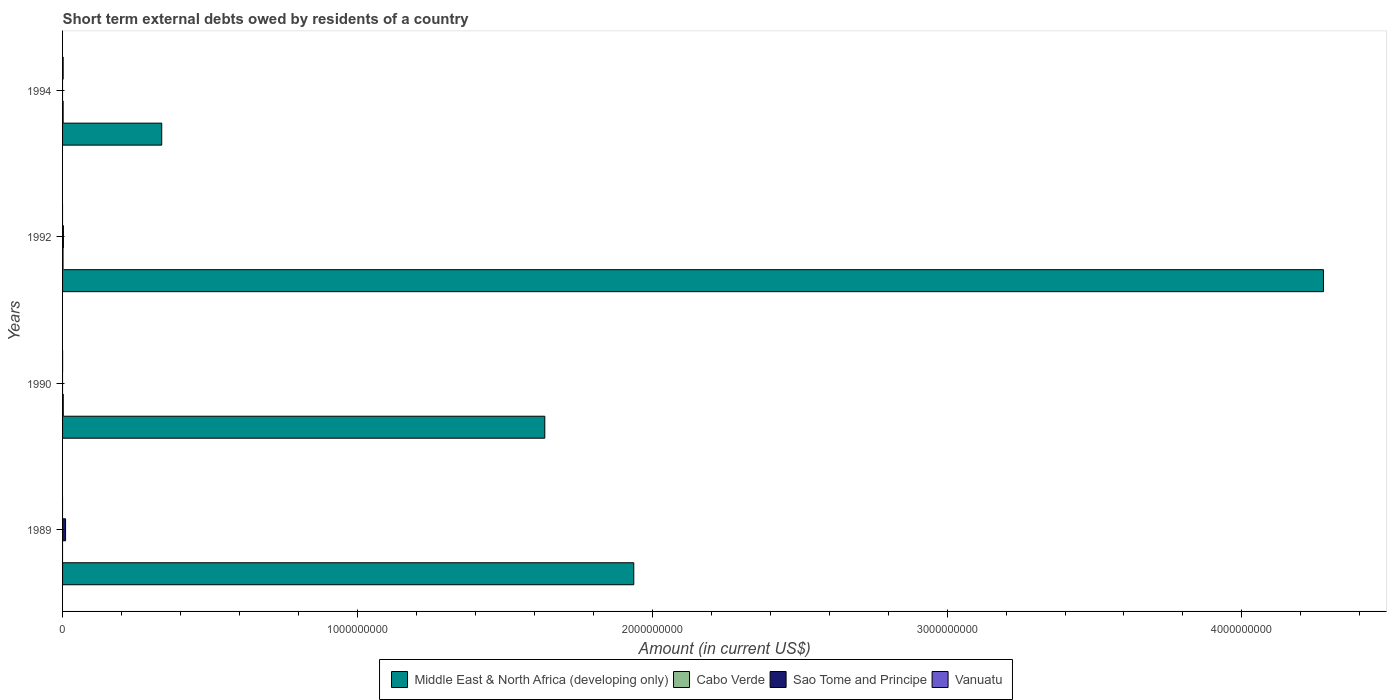How many different coloured bars are there?
Provide a succinct answer. 4. How many groups of bars are there?
Offer a very short reply. 4. How many bars are there on the 2nd tick from the top?
Your response must be concise. 3. How many bars are there on the 3rd tick from the bottom?
Your answer should be very brief. 3. In how many cases, is the number of bars for a given year not equal to the number of legend labels?
Provide a short and direct response. 4. What is the amount of short-term external debts owed by residents in Middle East & North Africa (developing only) in 1990?
Ensure brevity in your answer.  1.64e+09. Across all years, what is the maximum amount of short-term external debts owed by residents in Middle East & North Africa (developing only)?
Give a very brief answer. 4.28e+09. Across all years, what is the minimum amount of short-term external debts owed by residents in Sao Tome and Principe?
Your answer should be compact. 0. In which year was the amount of short-term external debts owed by residents in Cabo Verde maximum?
Your response must be concise. 1990. What is the total amount of short-term external debts owed by residents in Cabo Verde in the graph?
Offer a very short reply. 6.00e+06. What is the difference between the amount of short-term external debts owed by residents in Middle East & North Africa (developing only) in 1989 and that in 1994?
Provide a succinct answer. 1.60e+09. What is the difference between the amount of short-term external debts owed by residents in Sao Tome and Principe in 1990 and the amount of short-term external debts owed by residents in Cabo Verde in 1994?
Make the answer very short. -2.00e+06. What is the average amount of short-term external debts owed by residents in Sao Tome and Principe per year?
Your answer should be compact. 3.25e+06. In the year 1994, what is the difference between the amount of short-term external debts owed by residents in Middle East & North Africa (developing only) and amount of short-term external debts owed by residents in Vanuatu?
Provide a short and direct response. 3.34e+08. In how many years, is the amount of short-term external debts owed by residents in Sao Tome and Principe greater than 4000000000 US$?
Provide a short and direct response. 0. Is the amount of short-term external debts owed by residents in Cabo Verde in 1990 less than that in 1992?
Keep it short and to the point. No. What is the difference between the highest and the lowest amount of short-term external debts owed by residents in Middle East & North Africa (developing only)?
Ensure brevity in your answer.  3.94e+09. Is the sum of the amount of short-term external debts owed by residents in Cabo Verde in 1992 and 1994 greater than the maximum amount of short-term external debts owed by residents in Vanuatu across all years?
Offer a very short reply. Yes. How many years are there in the graph?
Give a very brief answer. 4. Are the values on the major ticks of X-axis written in scientific E-notation?
Ensure brevity in your answer.  No. Does the graph contain any zero values?
Your answer should be very brief. Yes. What is the title of the graph?
Ensure brevity in your answer.  Short term external debts owed by residents of a country. Does "Moldova" appear as one of the legend labels in the graph?
Your response must be concise. No. What is the label or title of the Y-axis?
Make the answer very short. Years. What is the Amount (in current US$) of Middle East & North Africa (developing only) in 1989?
Give a very brief answer. 1.94e+09. What is the Amount (in current US$) of Cabo Verde in 1989?
Your answer should be compact. 0. What is the Amount (in current US$) of Sao Tome and Principe in 1989?
Your response must be concise. 1.02e+07. What is the Amount (in current US$) of Vanuatu in 1989?
Your answer should be compact. 0. What is the Amount (in current US$) of Middle East & North Africa (developing only) in 1990?
Your answer should be very brief. 1.64e+09. What is the Amount (in current US$) in Cabo Verde in 1990?
Offer a terse response. 2.40e+06. What is the Amount (in current US$) of Sao Tome and Principe in 1990?
Provide a succinct answer. 0. What is the Amount (in current US$) of Middle East & North Africa (developing only) in 1992?
Offer a terse response. 4.28e+09. What is the Amount (in current US$) in Cabo Verde in 1992?
Your answer should be very brief. 1.60e+06. What is the Amount (in current US$) of Sao Tome and Principe in 1992?
Make the answer very short. 2.83e+06. What is the Amount (in current US$) of Vanuatu in 1992?
Give a very brief answer. 0. What is the Amount (in current US$) in Middle East & North Africa (developing only) in 1994?
Your response must be concise. 3.36e+08. What is the Amount (in current US$) of Cabo Verde in 1994?
Give a very brief answer. 2.00e+06. What is the Amount (in current US$) in Vanuatu in 1994?
Your answer should be very brief. 2.00e+06. Across all years, what is the maximum Amount (in current US$) of Middle East & North Africa (developing only)?
Provide a succinct answer. 4.28e+09. Across all years, what is the maximum Amount (in current US$) in Cabo Verde?
Give a very brief answer. 2.40e+06. Across all years, what is the maximum Amount (in current US$) of Sao Tome and Principe?
Ensure brevity in your answer.  1.02e+07. Across all years, what is the minimum Amount (in current US$) in Middle East & North Africa (developing only)?
Keep it short and to the point. 3.36e+08. Across all years, what is the minimum Amount (in current US$) of Cabo Verde?
Your response must be concise. 0. Across all years, what is the minimum Amount (in current US$) of Vanuatu?
Offer a very short reply. 0. What is the total Amount (in current US$) in Middle East & North Africa (developing only) in the graph?
Your answer should be compact. 8.19e+09. What is the total Amount (in current US$) in Cabo Verde in the graph?
Provide a succinct answer. 6.00e+06. What is the total Amount (in current US$) of Sao Tome and Principe in the graph?
Your answer should be compact. 1.30e+07. What is the total Amount (in current US$) in Vanuatu in the graph?
Provide a short and direct response. 2.10e+06. What is the difference between the Amount (in current US$) in Middle East & North Africa (developing only) in 1989 and that in 1990?
Your answer should be very brief. 3.02e+08. What is the difference between the Amount (in current US$) of Middle East & North Africa (developing only) in 1989 and that in 1992?
Offer a very short reply. -2.34e+09. What is the difference between the Amount (in current US$) of Sao Tome and Principe in 1989 and that in 1992?
Keep it short and to the point. 7.35e+06. What is the difference between the Amount (in current US$) in Middle East & North Africa (developing only) in 1989 and that in 1994?
Keep it short and to the point. 1.60e+09. What is the difference between the Amount (in current US$) of Middle East & North Africa (developing only) in 1990 and that in 1992?
Make the answer very short. -2.64e+09. What is the difference between the Amount (in current US$) of Middle East & North Africa (developing only) in 1990 and that in 1994?
Your response must be concise. 1.30e+09. What is the difference between the Amount (in current US$) of Vanuatu in 1990 and that in 1994?
Your answer should be very brief. -1.90e+06. What is the difference between the Amount (in current US$) of Middle East & North Africa (developing only) in 1992 and that in 1994?
Offer a very short reply. 3.94e+09. What is the difference between the Amount (in current US$) in Cabo Verde in 1992 and that in 1994?
Your answer should be very brief. -4.00e+05. What is the difference between the Amount (in current US$) in Middle East & North Africa (developing only) in 1989 and the Amount (in current US$) in Cabo Verde in 1990?
Ensure brevity in your answer.  1.94e+09. What is the difference between the Amount (in current US$) of Middle East & North Africa (developing only) in 1989 and the Amount (in current US$) of Vanuatu in 1990?
Make the answer very short. 1.94e+09. What is the difference between the Amount (in current US$) in Sao Tome and Principe in 1989 and the Amount (in current US$) in Vanuatu in 1990?
Your response must be concise. 1.01e+07. What is the difference between the Amount (in current US$) in Middle East & North Africa (developing only) in 1989 and the Amount (in current US$) in Cabo Verde in 1992?
Provide a succinct answer. 1.94e+09. What is the difference between the Amount (in current US$) of Middle East & North Africa (developing only) in 1989 and the Amount (in current US$) of Sao Tome and Principe in 1992?
Give a very brief answer. 1.93e+09. What is the difference between the Amount (in current US$) of Middle East & North Africa (developing only) in 1989 and the Amount (in current US$) of Cabo Verde in 1994?
Your answer should be compact. 1.94e+09. What is the difference between the Amount (in current US$) in Middle East & North Africa (developing only) in 1989 and the Amount (in current US$) in Vanuatu in 1994?
Your answer should be very brief. 1.94e+09. What is the difference between the Amount (in current US$) in Sao Tome and Principe in 1989 and the Amount (in current US$) in Vanuatu in 1994?
Keep it short and to the point. 8.18e+06. What is the difference between the Amount (in current US$) in Middle East & North Africa (developing only) in 1990 and the Amount (in current US$) in Cabo Verde in 1992?
Your response must be concise. 1.63e+09. What is the difference between the Amount (in current US$) in Middle East & North Africa (developing only) in 1990 and the Amount (in current US$) in Sao Tome and Principe in 1992?
Ensure brevity in your answer.  1.63e+09. What is the difference between the Amount (in current US$) in Cabo Verde in 1990 and the Amount (in current US$) in Sao Tome and Principe in 1992?
Your response must be concise. -4.30e+05. What is the difference between the Amount (in current US$) of Middle East & North Africa (developing only) in 1990 and the Amount (in current US$) of Cabo Verde in 1994?
Provide a short and direct response. 1.63e+09. What is the difference between the Amount (in current US$) in Middle East & North Africa (developing only) in 1990 and the Amount (in current US$) in Vanuatu in 1994?
Ensure brevity in your answer.  1.63e+09. What is the difference between the Amount (in current US$) of Middle East & North Africa (developing only) in 1992 and the Amount (in current US$) of Cabo Verde in 1994?
Provide a succinct answer. 4.27e+09. What is the difference between the Amount (in current US$) in Middle East & North Africa (developing only) in 1992 and the Amount (in current US$) in Vanuatu in 1994?
Provide a short and direct response. 4.27e+09. What is the difference between the Amount (in current US$) of Cabo Verde in 1992 and the Amount (in current US$) of Vanuatu in 1994?
Ensure brevity in your answer.  -4.00e+05. What is the difference between the Amount (in current US$) in Sao Tome and Principe in 1992 and the Amount (in current US$) in Vanuatu in 1994?
Your response must be concise. 8.30e+05. What is the average Amount (in current US$) in Middle East & North Africa (developing only) per year?
Offer a terse response. 2.05e+09. What is the average Amount (in current US$) in Cabo Verde per year?
Your answer should be compact. 1.50e+06. What is the average Amount (in current US$) in Sao Tome and Principe per year?
Provide a short and direct response. 3.25e+06. What is the average Amount (in current US$) in Vanuatu per year?
Offer a very short reply. 5.25e+05. In the year 1989, what is the difference between the Amount (in current US$) in Middle East & North Africa (developing only) and Amount (in current US$) in Sao Tome and Principe?
Make the answer very short. 1.93e+09. In the year 1990, what is the difference between the Amount (in current US$) in Middle East & North Africa (developing only) and Amount (in current US$) in Cabo Verde?
Keep it short and to the point. 1.63e+09. In the year 1990, what is the difference between the Amount (in current US$) of Middle East & North Africa (developing only) and Amount (in current US$) of Vanuatu?
Make the answer very short. 1.64e+09. In the year 1990, what is the difference between the Amount (in current US$) of Cabo Verde and Amount (in current US$) of Vanuatu?
Offer a terse response. 2.30e+06. In the year 1992, what is the difference between the Amount (in current US$) of Middle East & North Africa (developing only) and Amount (in current US$) of Cabo Verde?
Keep it short and to the point. 4.27e+09. In the year 1992, what is the difference between the Amount (in current US$) in Middle East & North Africa (developing only) and Amount (in current US$) in Sao Tome and Principe?
Your response must be concise. 4.27e+09. In the year 1992, what is the difference between the Amount (in current US$) of Cabo Verde and Amount (in current US$) of Sao Tome and Principe?
Your response must be concise. -1.23e+06. In the year 1994, what is the difference between the Amount (in current US$) of Middle East & North Africa (developing only) and Amount (in current US$) of Cabo Verde?
Give a very brief answer. 3.34e+08. In the year 1994, what is the difference between the Amount (in current US$) in Middle East & North Africa (developing only) and Amount (in current US$) in Vanuatu?
Ensure brevity in your answer.  3.34e+08. In the year 1994, what is the difference between the Amount (in current US$) of Cabo Verde and Amount (in current US$) of Vanuatu?
Your answer should be compact. 0. What is the ratio of the Amount (in current US$) in Middle East & North Africa (developing only) in 1989 to that in 1990?
Ensure brevity in your answer.  1.18. What is the ratio of the Amount (in current US$) in Middle East & North Africa (developing only) in 1989 to that in 1992?
Offer a very short reply. 0.45. What is the ratio of the Amount (in current US$) in Sao Tome and Principe in 1989 to that in 1992?
Provide a succinct answer. 3.6. What is the ratio of the Amount (in current US$) in Middle East & North Africa (developing only) in 1989 to that in 1994?
Make the answer very short. 5.76. What is the ratio of the Amount (in current US$) in Middle East & North Africa (developing only) in 1990 to that in 1992?
Your response must be concise. 0.38. What is the ratio of the Amount (in current US$) in Cabo Verde in 1990 to that in 1992?
Provide a succinct answer. 1.5. What is the ratio of the Amount (in current US$) of Middle East & North Africa (developing only) in 1990 to that in 1994?
Make the answer very short. 4.86. What is the ratio of the Amount (in current US$) in Middle East & North Africa (developing only) in 1992 to that in 1994?
Your answer should be compact. 12.72. What is the ratio of the Amount (in current US$) in Cabo Verde in 1992 to that in 1994?
Offer a very short reply. 0.8. What is the difference between the highest and the second highest Amount (in current US$) in Middle East & North Africa (developing only)?
Keep it short and to the point. 2.34e+09. What is the difference between the highest and the second highest Amount (in current US$) in Cabo Verde?
Offer a very short reply. 4.00e+05. What is the difference between the highest and the lowest Amount (in current US$) in Middle East & North Africa (developing only)?
Your response must be concise. 3.94e+09. What is the difference between the highest and the lowest Amount (in current US$) in Cabo Verde?
Your answer should be very brief. 2.40e+06. What is the difference between the highest and the lowest Amount (in current US$) of Sao Tome and Principe?
Keep it short and to the point. 1.02e+07. What is the difference between the highest and the lowest Amount (in current US$) in Vanuatu?
Give a very brief answer. 2.00e+06. 